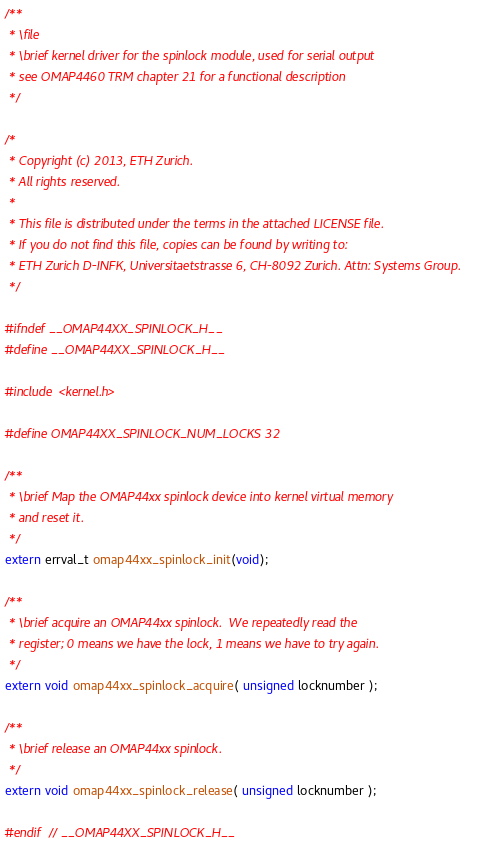Convert code to text. <code><loc_0><loc_0><loc_500><loc_500><_C_>/**
 * \file
 * \brief kernel driver for the spinlock module, used for serial output
 * see OMAP4460 TRM chapter 21 for a functional description
 */

/*
 * Copyright (c) 2013, ETH Zurich.
 * All rights reserved.
 *
 * This file is distributed under the terms in the attached LICENSE file.
 * If you do not find this file, copies can be found by writing to:
 * ETH Zurich D-INFK, Universitaetstrasse 6, CH-8092 Zurich. Attn: Systems Group.
 */

#ifndef __OMAP44XX_SPINLOCK_H__
#define __OMAP44XX_SPINLOCK_H__

#include <kernel.h>

#define OMAP44XX_SPINLOCK_NUM_LOCKS 32

/**
 * \brief Map the OMAP44xx spinlock device into kernel virtual memory
 * and reset it. 
 */
extern errval_t omap44xx_spinlock_init(void);

/**
 * \brief acquire an OMAP44xx spinlock.  We repeatedly read the
 * register; 0 means we have the lock, 1 means we have to try again. 
 */
extern void omap44xx_spinlock_acquire( unsigned locknumber );

/**
 * \brief release an OMAP44xx spinlock.
 */
extern void omap44xx_spinlock_release( unsigned locknumber );

#endif  // __OMAP44XX_SPINLOCK_H__
</code> 